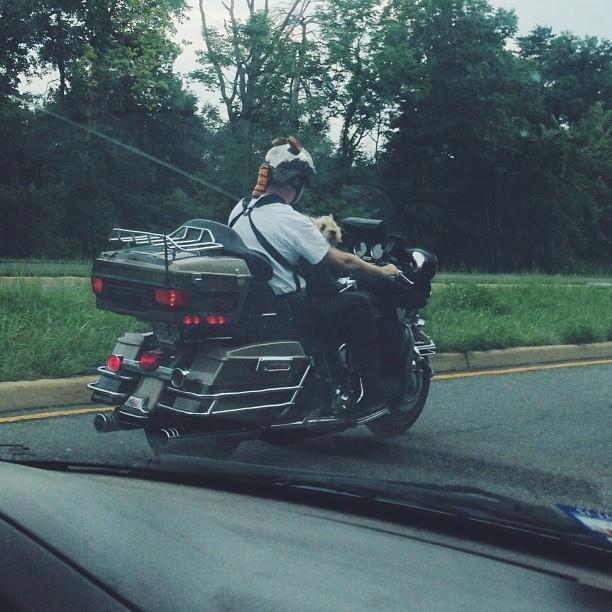How many wheels are in this picture?
Give a very brief answer. 2. 